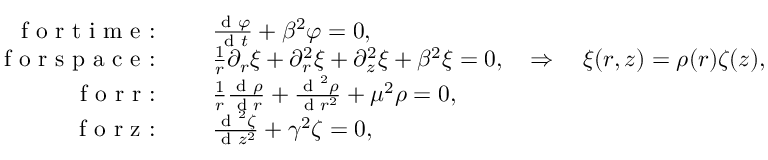<formula> <loc_0><loc_0><loc_500><loc_500>\begin{array} { r l } { f o r t i m e \colon \quad } & \frac { d \varphi } { d t } + \beta ^ { 2 } \varphi = 0 , } \\ { f o r s p a c e \colon \quad } & \frac { 1 } { r } \partial _ { r } \xi + \partial _ { r } ^ { 2 } \xi + \partial _ { z } ^ { 2 } \xi + \beta ^ { 2 } \xi = 0 , \quad \Rightarrow \quad \xi ( r , z ) = \rho ( r ) \zeta ( z ) , \quad \Rightarrow } \\ { f o r r \colon \quad } & \frac { 1 } { r } \frac { d \rho } { d r } + \frac { d ^ { 2 } \rho } { d r ^ { 2 } } + \mu ^ { 2 } \rho = 0 , } \\ { f o r z \colon \quad } & \frac { d ^ { 2 } \zeta } { d z ^ { 2 } } + \gamma ^ { 2 } \zeta = 0 , } \end{array}</formula> 